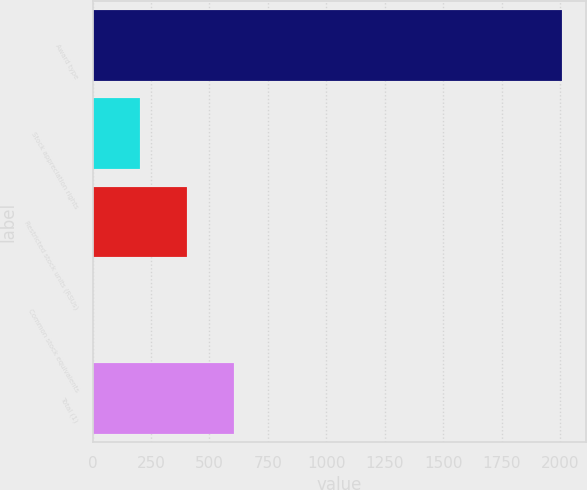Convert chart to OTSL. <chart><loc_0><loc_0><loc_500><loc_500><bar_chart><fcel>Award type<fcel>Stock appreciation rights<fcel>Restricted stock units (RSUs)<fcel>Common stock equivalents<fcel>Total (1)<nl><fcel>2010<fcel>201.45<fcel>402.4<fcel>0.5<fcel>603.35<nl></chart> 